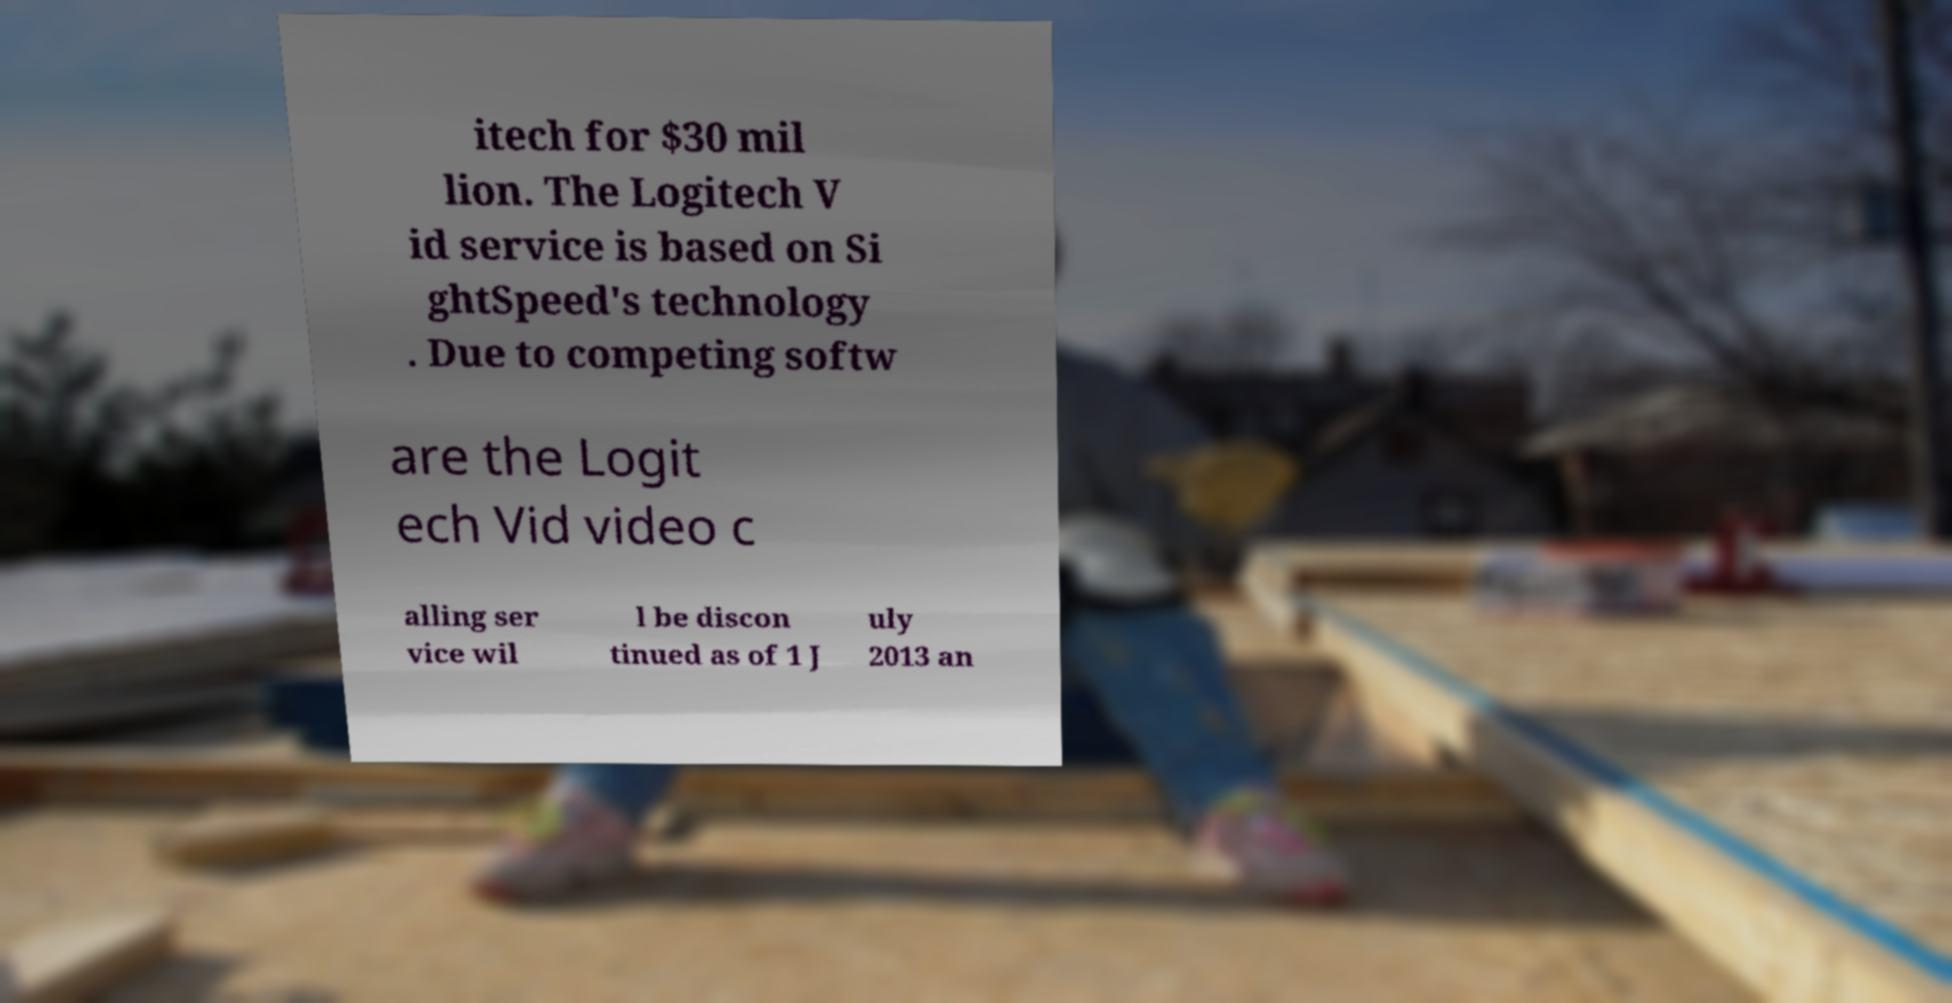I need the written content from this picture converted into text. Can you do that? itech for $30 mil lion. The Logitech V id service is based on Si ghtSpeed's technology . Due to competing softw are the Logit ech Vid video c alling ser vice wil l be discon tinued as of 1 J uly 2013 an 